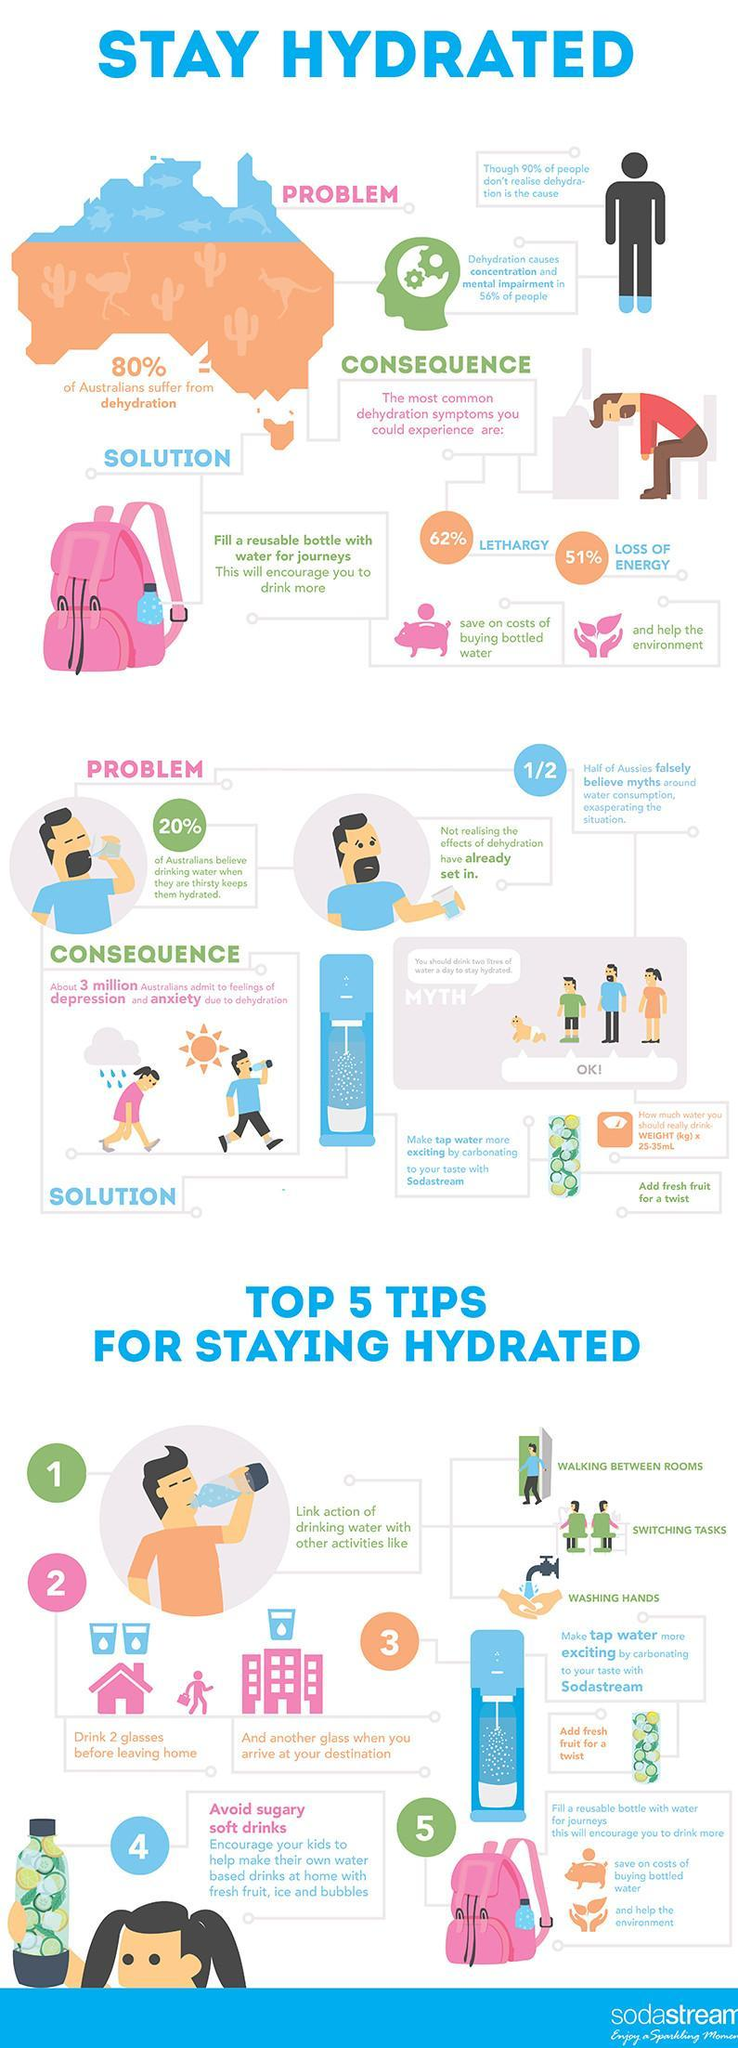What percentage of Australians do not suffer from dehydration?
Answer the question with a short phrase. 20% What percentage of Australians could experience loss of energy as the most common dehydration system? 51% What percentage of Australians have concentration & mental impairment due to dehydration? 56% What percentage of Australians could experience lethargy as the most common dehydration system? 62% 